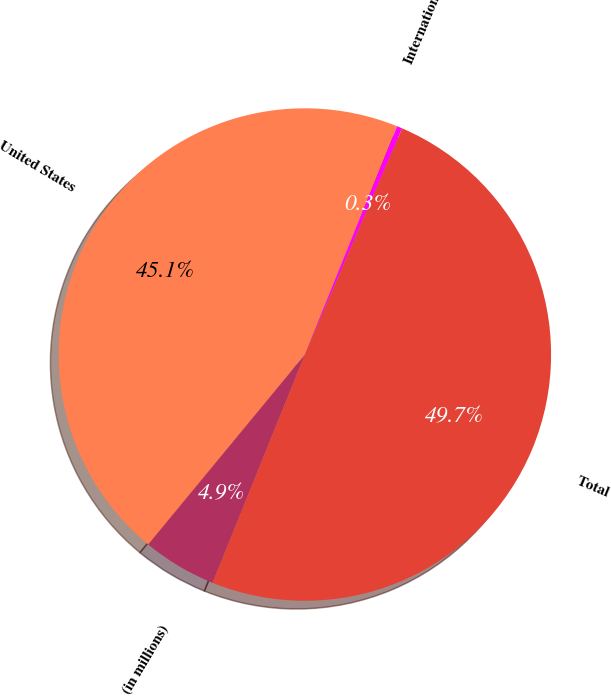Convert chart to OTSL. <chart><loc_0><loc_0><loc_500><loc_500><pie_chart><fcel>(in millions)<fcel>United States<fcel>International<fcel>Total<nl><fcel>4.87%<fcel>45.13%<fcel>0.35%<fcel>49.65%<nl></chart> 